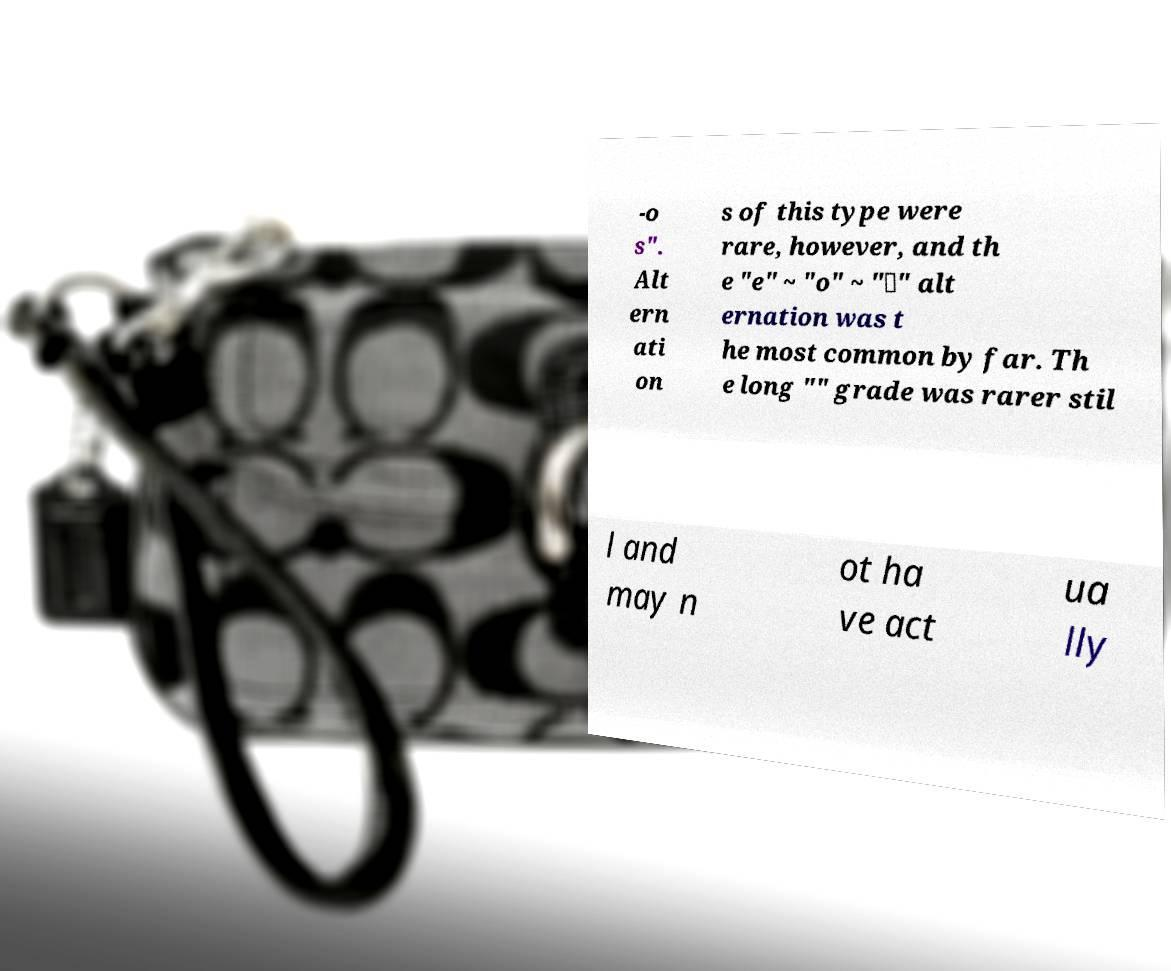Can you accurately transcribe the text from the provided image for me? -o s". Alt ern ati on s of this type were rare, however, and th e "e" ~ "o" ~ "∅" alt ernation was t he most common by far. Th e long "" grade was rarer stil l and may n ot ha ve act ua lly 